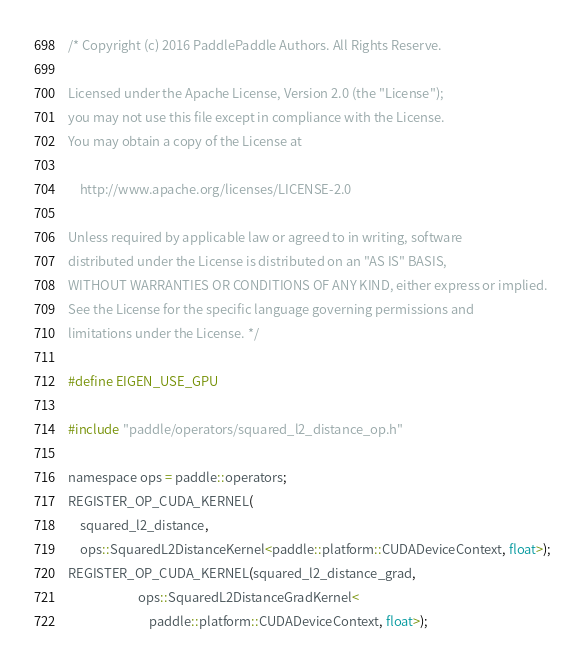Convert code to text. <code><loc_0><loc_0><loc_500><loc_500><_Cuda_>/* Copyright (c) 2016 PaddlePaddle Authors. All Rights Reserve.

Licensed under the Apache License, Version 2.0 (the "License");
you may not use this file except in compliance with the License.
You may obtain a copy of the License at

    http://www.apache.org/licenses/LICENSE-2.0

Unless required by applicable law or agreed to in writing, software
distributed under the License is distributed on an "AS IS" BASIS,
WITHOUT WARRANTIES OR CONDITIONS OF ANY KIND, either express or implied.
See the License for the specific language governing permissions and
limitations under the License. */

#define EIGEN_USE_GPU

#include "paddle/operators/squared_l2_distance_op.h"

namespace ops = paddle::operators;
REGISTER_OP_CUDA_KERNEL(
    squared_l2_distance,
    ops::SquaredL2DistanceKernel<paddle::platform::CUDADeviceContext, float>);
REGISTER_OP_CUDA_KERNEL(squared_l2_distance_grad,
                        ops::SquaredL2DistanceGradKernel<
                            paddle::platform::CUDADeviceContext, float>);
</code> 